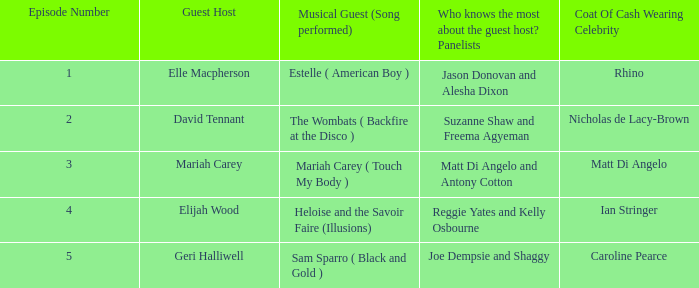Name the total number of coat of cash wearing celebrity where panelists are matt di angelo and antony cotton 1.0. 